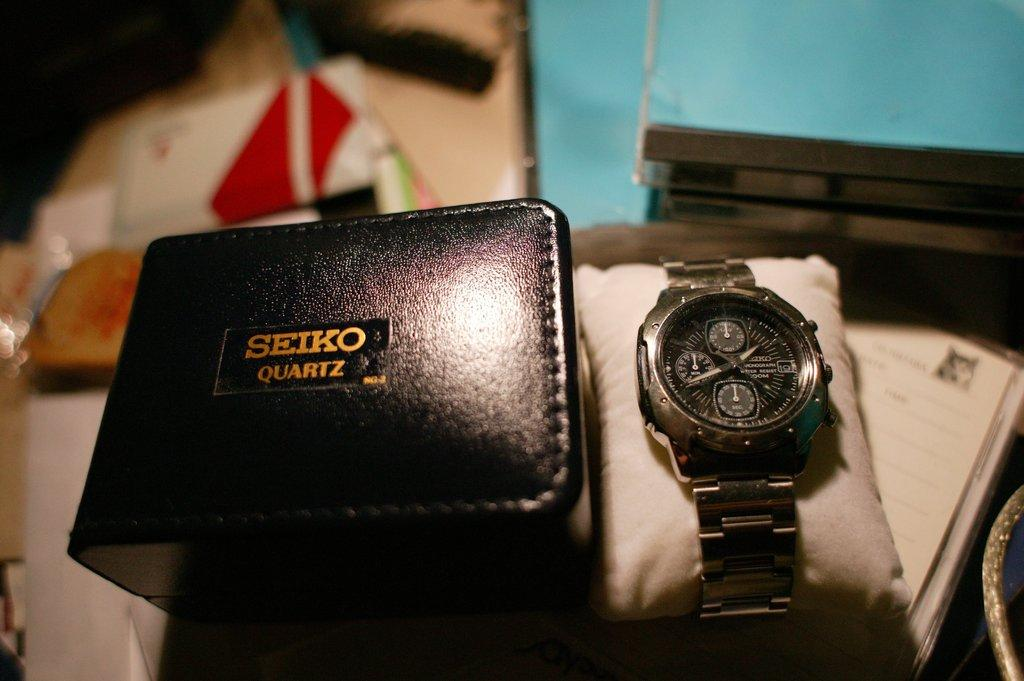<image>
Give a short and clear explanation of the subsequent image. A watch next to a case reading Seiko Quartz 